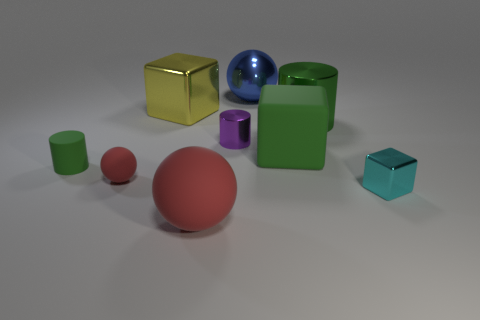How many green cylinders must be subtracted to get 1 green cylinders? 1 Subtract all tiny cylinders. How many cylinders are left? 1 Add 1 big cylinders. How many objects exist? 10 Subtract 1 spheres. How many spheres are left? 2 Subtract all green cylinders. How many cylinders are left? 1 Subtract all balls. How many objects are left? 6 Add 3 blue things. How many blue things are left? 4 Add 7 purple shiny cylinders. How many purple shiny cylinders exist? 8 Subtract 2 green cylinders. How many objects are left? 7 Subtract all cyan cylinders. Subtract all green cubes. How many cylinders are left? 3 